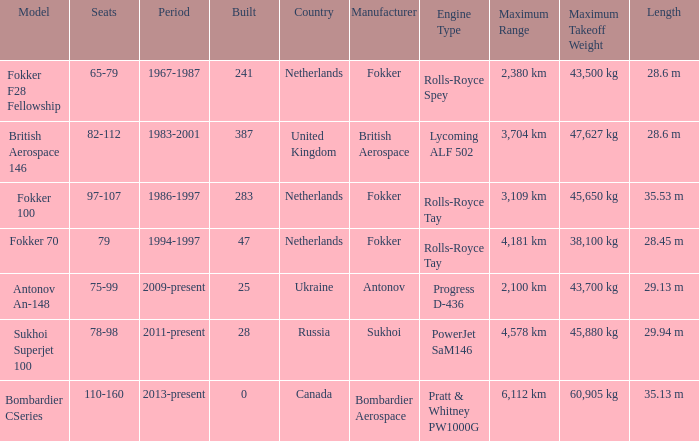Would you be able to parse every entry in this table? {'header': ['Model', 'Seats', 'Period', 'Built', 'Country', 'Manufacturer', 'Engine Type', 'Maximum Range', 'Maximum Takeoff Weight', 'Length'], 'rows': [['Fokker F28 Fellowship', '65-79', '1967-1987', '241', 'Netherlands', 'Fokker', 'Rolls-Royce Spey', '2,380 km', '43,500 kg', '28.6 m'], ['British Aerospace 146', '82-112', '1983-2001', '387', 'United Kingdom', 'British Aerospace', 'Lycoming ALF 502', '3,704 km', '47,627 kg', '28.6 m'], ['Fokker 100', '97-107', '1986-1997', '283', 'Netherlands', 'Fokker', 'Rolls-Royce Tay', '3,109 km', '45,650 kg', '35.53 m'], ['Fokker 70', '79', '1994-1997', '47', 'Netherlands', 'Fokker', 'Rolls-Royce Tay', '4,181 km', '38,100 kg', '28.45 m'], ['Antonov An-148', '75-99', '2009-present', '25', 'Ukraine', 'Antonov', 'Progress D-436', '2,100 km', '43,700 kg', '29.13 m'], ['Sukhoi Superjet 100', '78-98', '2011-present', '28', 'Russia', 'Sukhoi', 'PowerJet SaM146', '4,578 km', '45,880 kg', '29.94 m'], ['Bombardier CSeries', '110-160', '2013-present', '0', 'Canada', 'Bombardier Aerospace', 'Pratt & Whitney PW1000G', '6,112 km', '60,905 kg', '35.13 m']]} How many cabins were built in the time between 1967-1987? 241.0. 